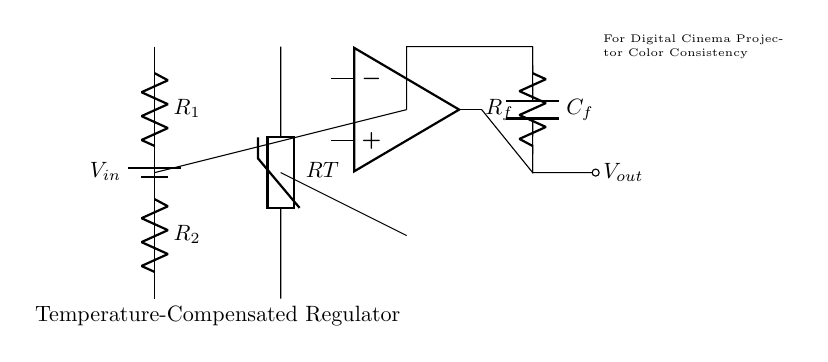What is the input voltage of the circuit? The input voltage, labeled as V sub in, is indicated by the battery symbol at the top left of the diagram.
Answer: V sub in What type of sensor is used in this circuit? The sensor is specified as a thermistor, depicted at the left center of the circuit diagram.
Answer: Thermistor What is the purpose of the operational amplifier in this circuit? The operational amplifier is used to amplify the difference in voltage between its input terminals, which helps maintain a stable output voltage for the regulator.
Answer: Amplification What does the feedback capacitor do in this circuit? The feedback capacitor, labeled C sub f, helps stabilize the output voltage by smoothing out fluctuations and providing a consistent response to the input changes.
Answer: Stabilization How many resistors are present in the circuit? There are two resistors in the voltage divider section of the circuit, shown as R sub 1 and R sub 2.
Answer: Two What is the role of the resistors R1 and R2 in the circuit? R1 and R2 act as a voltage divider, generating a reference voltage for the operational amplifier input based on the input voltage.
Answer: Voltage divider How does this circuit maintain color consistency in digital cinema projectors? The circuit maintains color consistency by ensuring that the output voltage, which affects the projector's color output, remains stable regardless of temperature changes, achieved through temperature compensation techniques.
Answer: Temperature compensation 